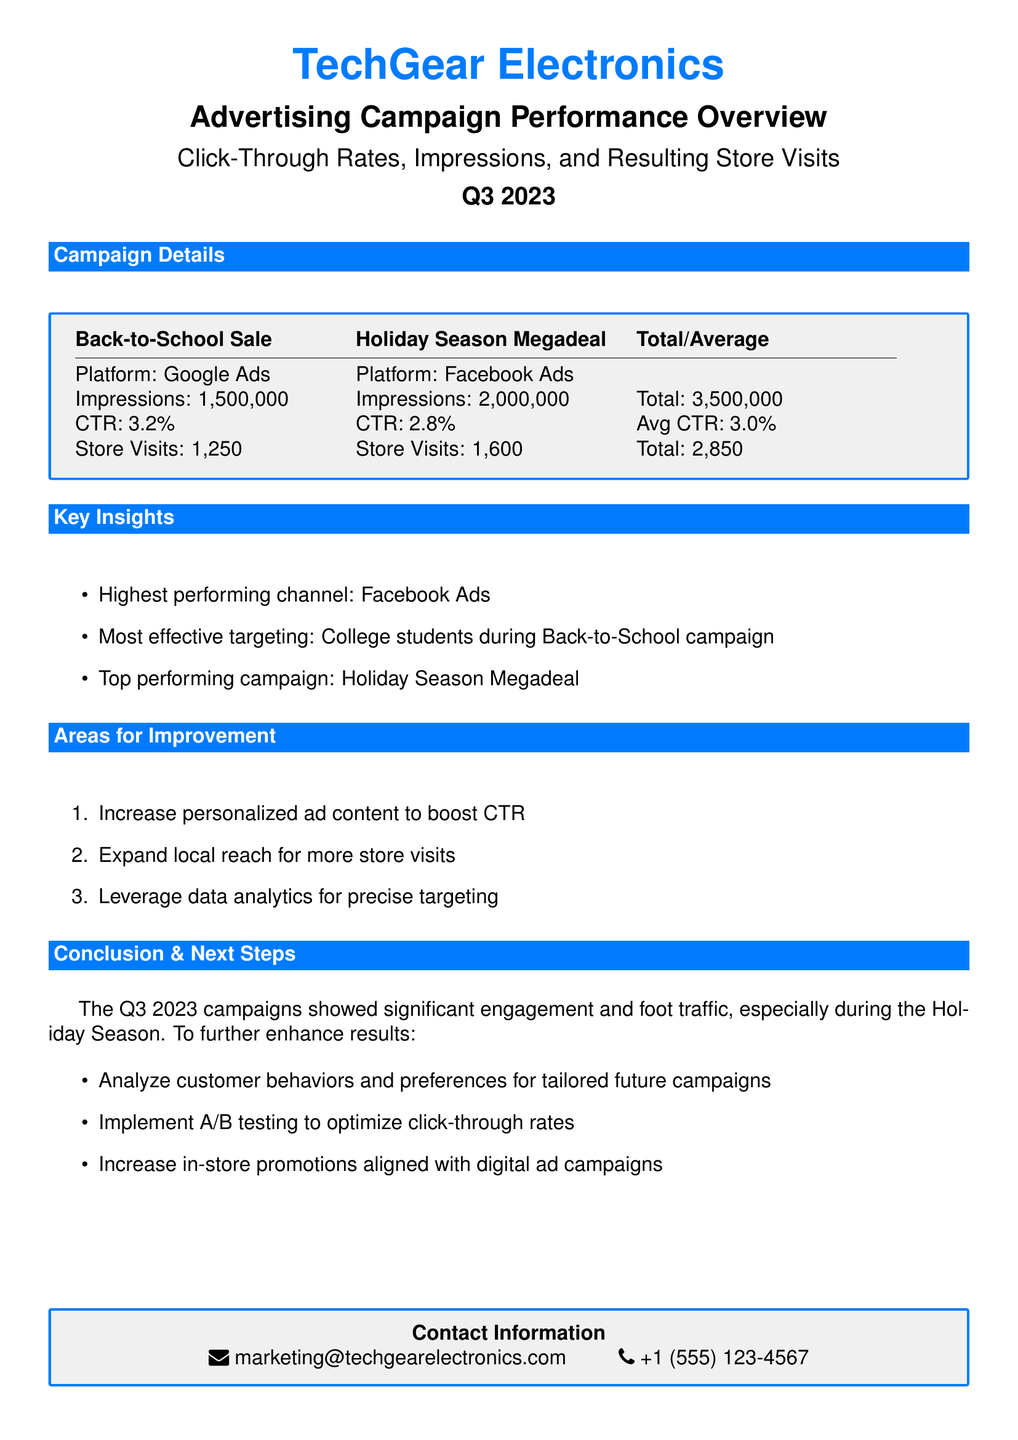What is the total number of impressions for all campaigns? The total number of impressions is calculated by adding the impressions from both campaigns, which are 1,500,000 and 2,000,000.
Answer: 3,500,000 Which campaign had the highest click-through rate (CTR)? The campaign with the highest CTR is identified from the provided CTR values of both campaigns, where Back-to-School Sale has a CTR of 3.2% and Holiday Season Megadeal has a CTR of 2.8%.
Answer: Back-to-School Sale How many store visits resulted from the Holiday Season Megadeal campaign? The number of store visits is directly stated in the document for the Holiday Season Megadeal, which is 1,600.
Answer: 1,600 What is the average click-through rate (CTR) for the campaigns? The average CTR is calculated from the CTR of both campaigns, which are 3.2% and 2.8%, with the total given in the document.
Answer: 3.0% What is one area for improvement mentioned in the document? The document lists areas for improvement, one of which is to increase personalized ad content to boost CTR.
Answer: Increase personalized ad content Which advertising platform showed the most effective targeting? The document indicates the most effective targeting identifier, particularly for the Back-to-School campaign, which targeted college students.
Answer: College students What is one next step suggested for future campaigns? The document outlines suggested next steps for future campaigns, one of which is to analyze customer behaviors and preferences.
Answer: Analyze customer behaviors and preferences What type of ad campaign was the top performing one? The top-performing campaign is labeled in the document, specifically during the Holiday Season.
Answer: Holiday Season Megadeal 